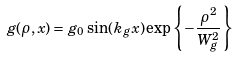Convert formula to latex. <formula><loc_0><loc_0><loc_500><loc_500>g ( \rho , x ) = g _ { 0 } \sin ( k _ { g } x ) \exp \left \{ - \frac { \rho ^ { 2 } } { W _ { g } ^ { 2 } } \right \}</formula> 